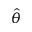Convert formula to latex. <formula><loc_0><loc_0><loc_500><loc_500>\hat { \theta }</formula> 